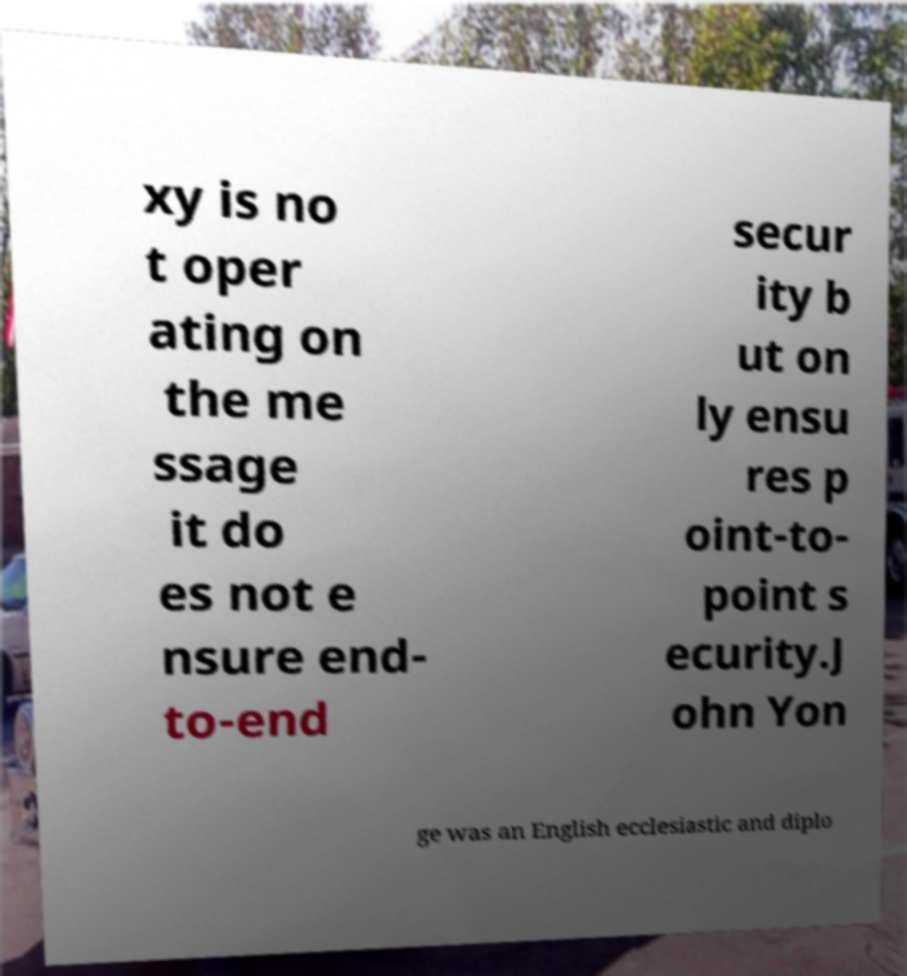Can you accurately transcribe the text from the provided image for me? xy is no t oper ating on the me ssage it do es not e nsure end- to-end secur ity b ut on ly ensu res p oint-to- point s ecurity.J ohn Yon ge was an English ecclesiastic and diplo 